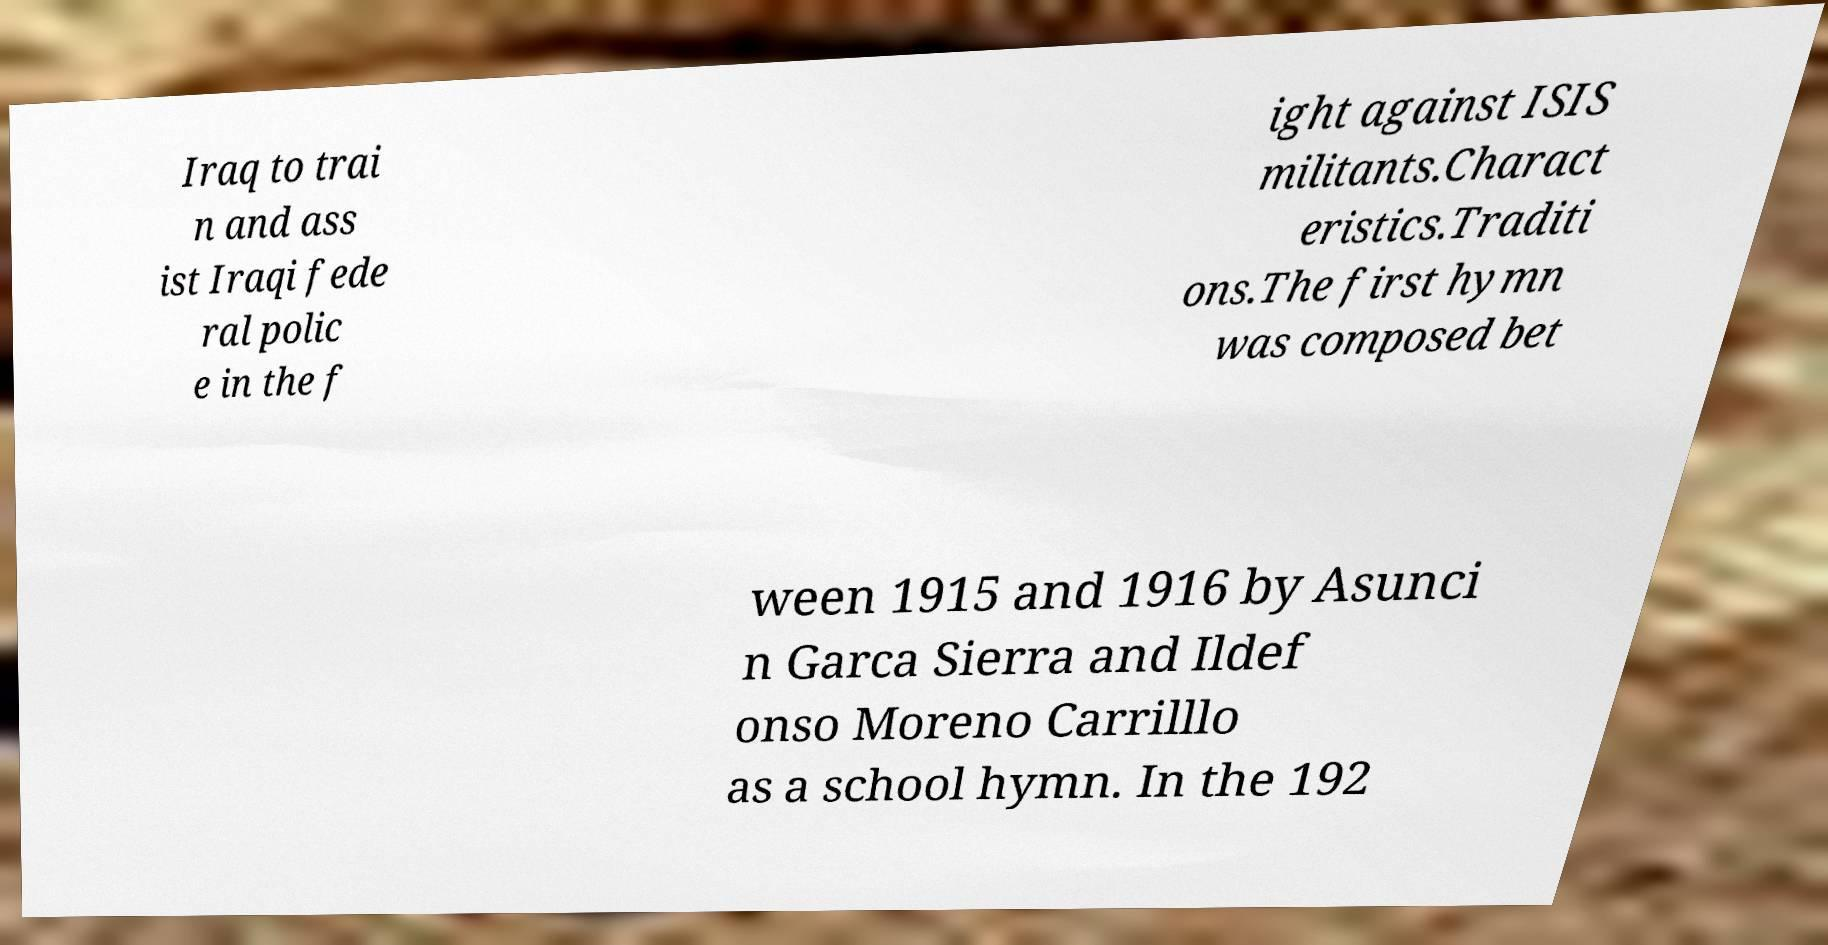Can you read and provide the text displayed in the image?This photo seems to have some interesting text. Can you extract and type it out for me? Iraq to trai n and ass ist Iraqi fede ral polic e in the f ight against ISIS militants.Charact eristics.Traditi ons.The first hymn was composed bet ween 1915 and 1916 by Asunci n Garca Sierra and Ildef onso Moreno Carrilllo as a school hymn. In the 192 